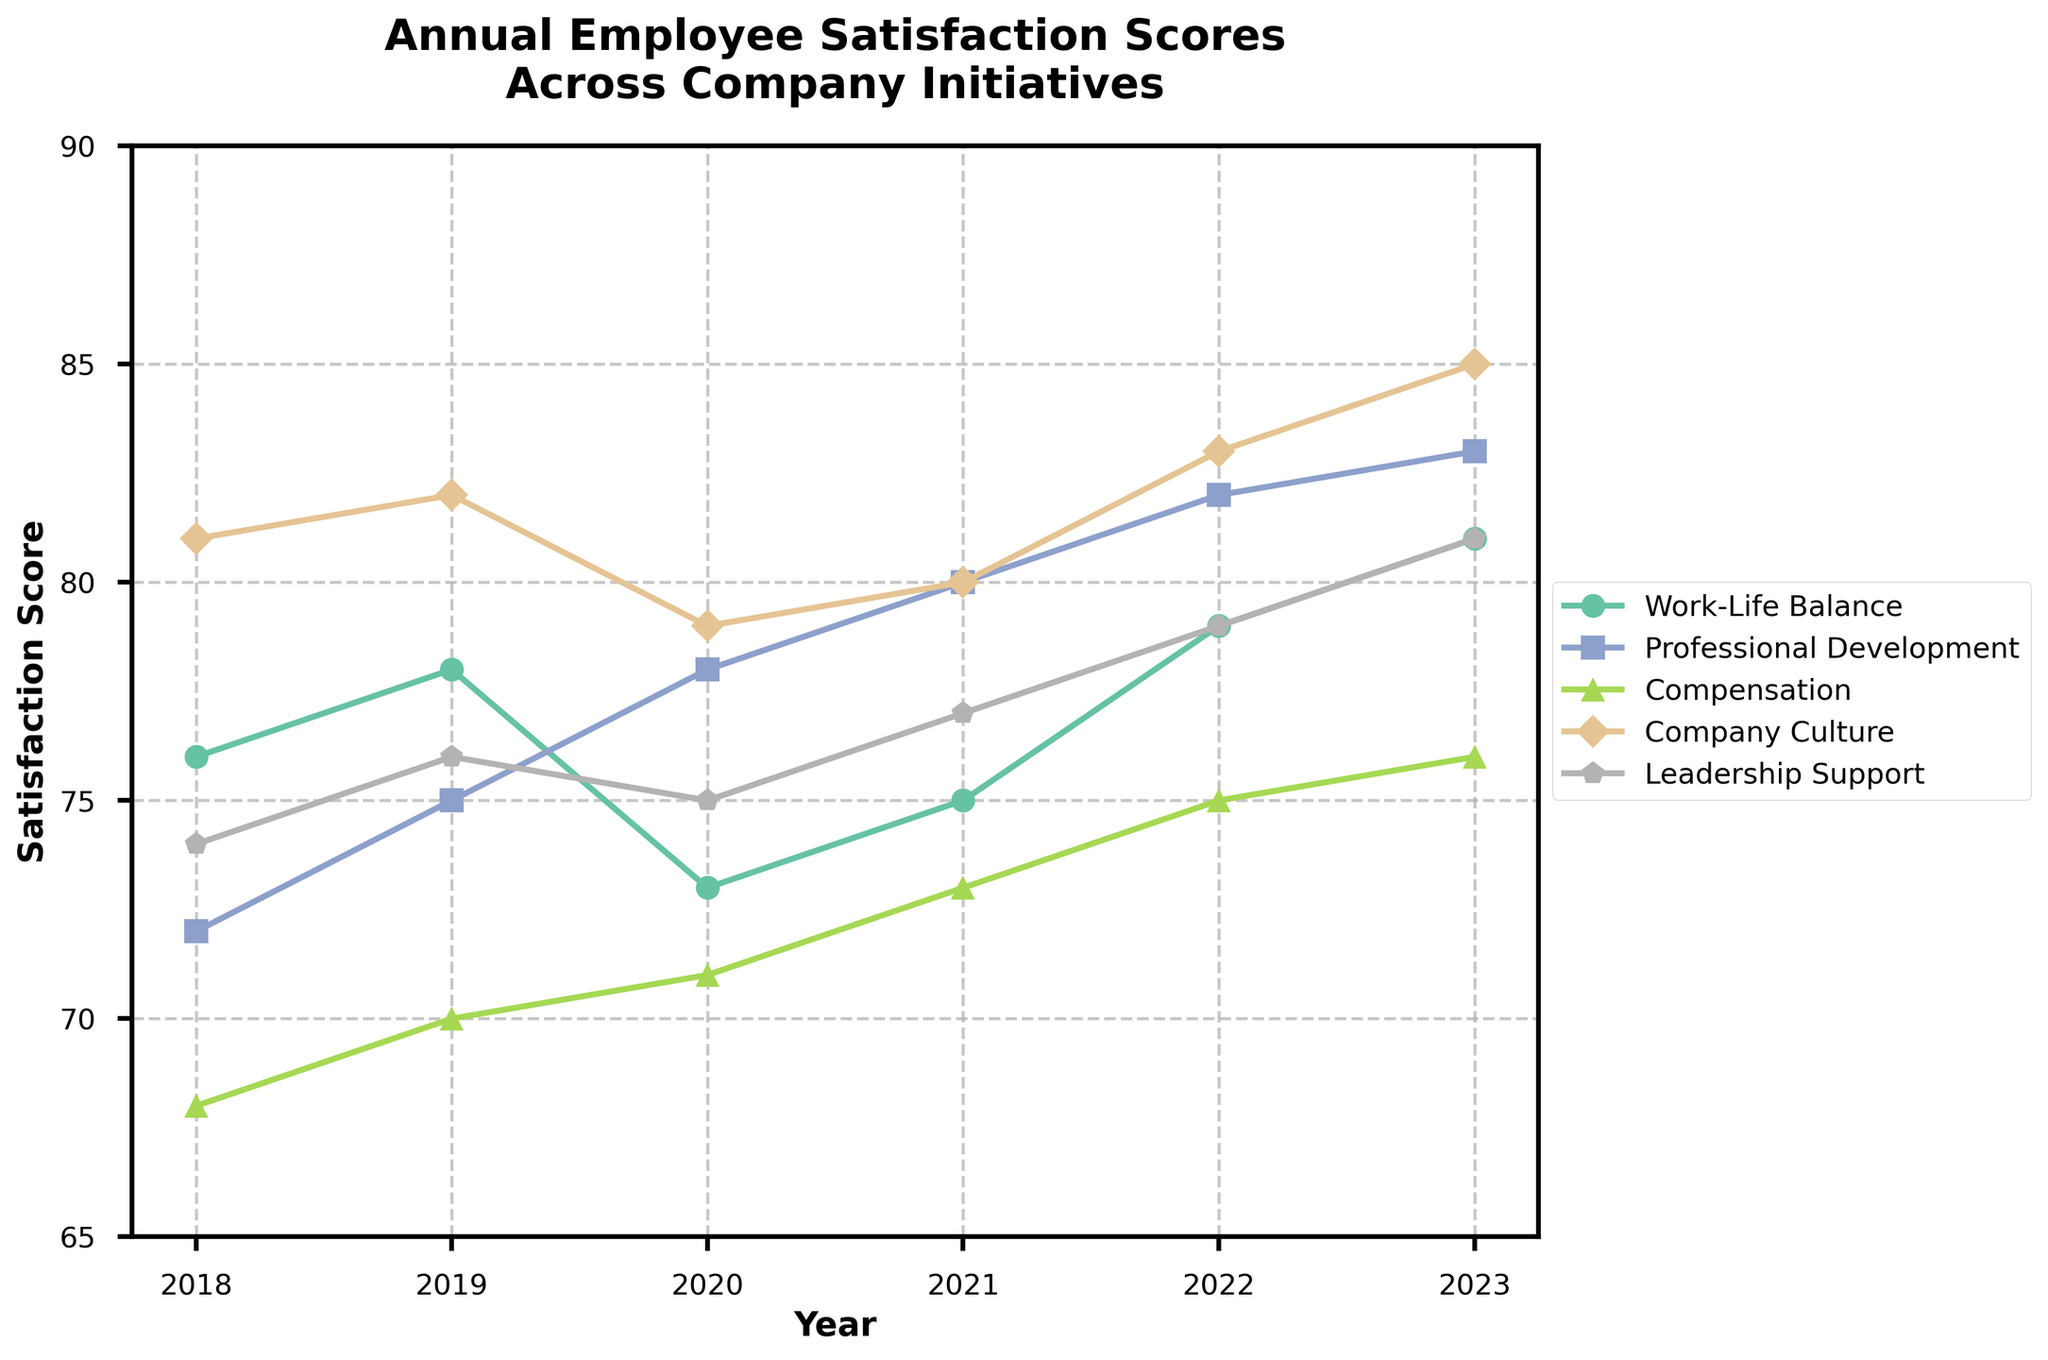What is the trend for employee satisfaction with Professional Development from 2018 to 2023? The line for Professional Development starts at 72 in 2018 and gradually increases to 83 in 2023, indicating a positive trend over the years.
Answer: Positive, increasing Which initiative had the highest satisfaction score in 2021? In 2021, Company Culture had the highest satisfaction score as indicated by the highest point on the plot for that year.
Answer: Company Culture How did Work-Life Balance change from 2020 to 2023? In 2020, the Work-Life Balance score was 73. It increased to 75 in 2021, 79 in 2022, and finally reached 81 in 2023.
Answer: It increased from 73 to 81 Which initiative showed the most improvement from 2018 to 2023? Comparing the scores from 2018 to 2023 for all initiatives, Professional Development showed the most improvement, increasing from 72 to 83, a difference of 11 points.
Answer: Professional Development Did any initiative score above 80 in 2018? In 2018, only Company Culture scored above 80 with a score of 81.
Answer: Company Culture What is the overall average satisfaction score for Leadership Support between 2018 and 2023? Adding the scores for Leadership Support from 2018 to 2023 and dividing by the number of years, (74 + 76 + 75 + 77 + 79 + 81) / 6 = 462 / 6.
Answer: 77 Compare the trends of Work-Life Balance and Compensation from 2018 to 2023. Work-Life Balance shows an increasing trend starting at 76 and ending at 81, while Compensation also shows an increasing trend but at a slower rate, going from 68 to 76.
Answer: Work-Life Balance increased faster than Compensation What is the difference in satisfaction scores for Company Culture between 2019 and 2022? The score for Company Culture was 82 in 2019 and 83 in 2022, so the difference is 83 - 82.
Answer: 1 How does the satisfaction score for Professional Development in 2023 compare with the other initiatives in the same year? In 2023, the satisfaction score for Professional Development is 83. Comparing it with other initiatives, Work-Life Balance (81), Compensation (76), Company Culture (85), and Leadership Support (81), it is the second highest after Company Culture.
Answer: Second highest (after Company Culture) What can you infer about Compensation trends over the six years? Compensation starts at 68 in 2018 and shows a steady increase over the years, reaching 76 in 2023, indicating a gradual improvement.
Answer: Gradual improvement 